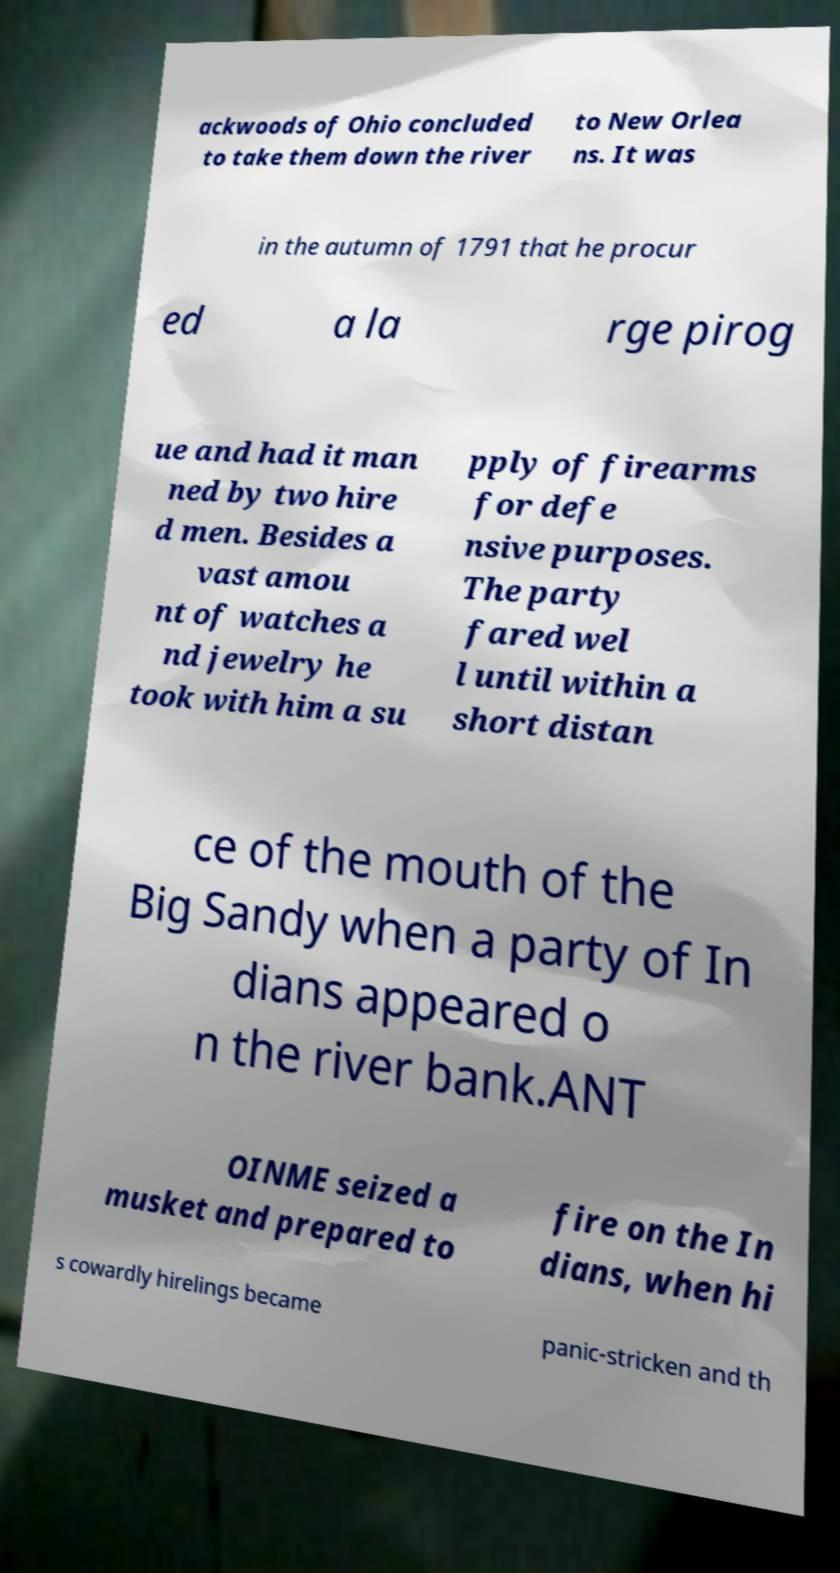There's text embedded in this image that I need extracted. Can you transcribe it verbatim? ackwoods of Ohio concluded to take them down the river to New Orlea ns. It was in the autumn of 1791 that he procur ed a la rge pirog ue and had it man ned by two hire d men. Besides a vast amou nt of watches a nd jewelry he took with him a su pply of firearms for defe nsive purposes. The party fared wel l until within a short distan ce of the mouth of the Big Sandy when a party of In dians appeared o n the river bank.ANT OINME seized a musket and prepared to fire on the In dians, when hi s cowardly hirelings became panic-stricken and th 